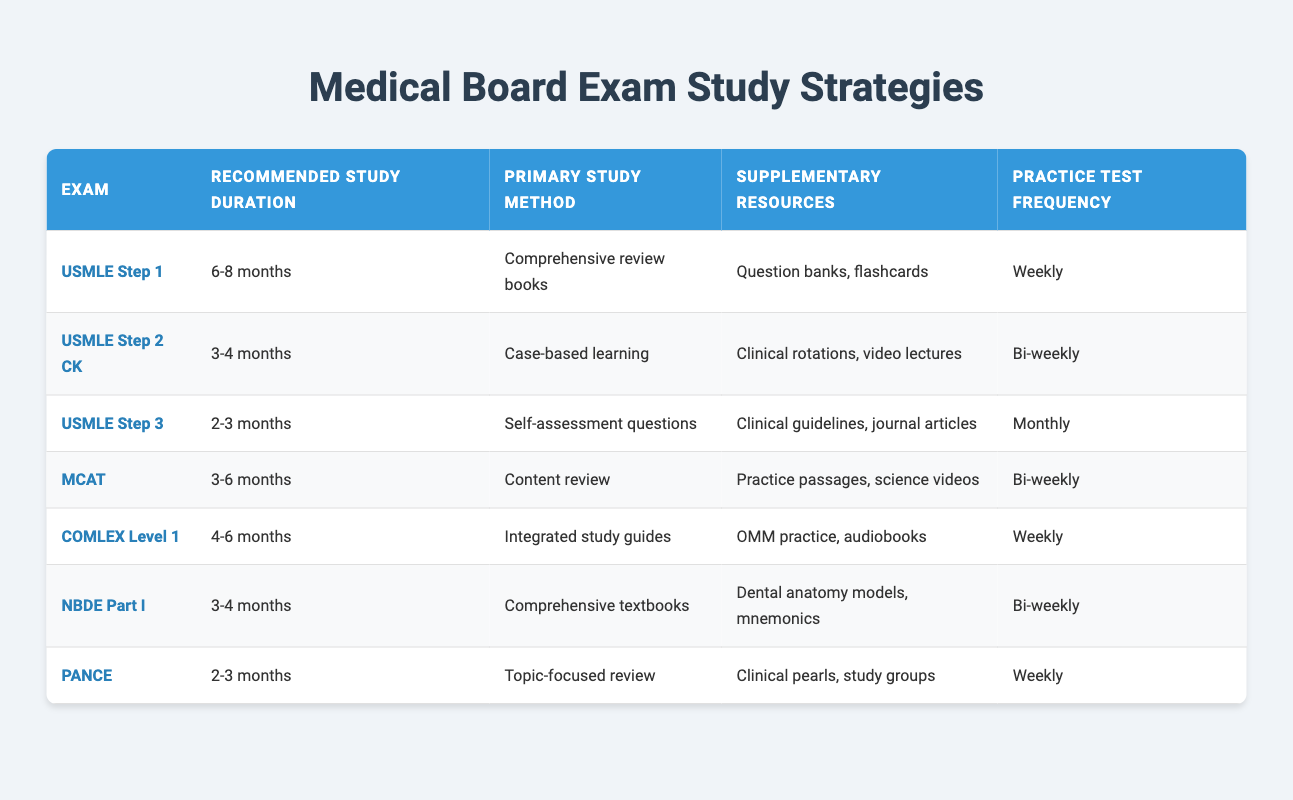What is the recommended study duration for USMLE Step 1? The table shows that the recommended study duration for USMLE Step 1 is "6-8 months". This information can be found directly in the corresponding row for this exam.
Answer: 6-8 months What is the primary study method for the MCAT? According to the table, the primary study method for the MCAT is "Content review". This is stated in the row related to the MCAT.
Answer: Content review How often should a student take practice tests for COMLEX Level 1? The table indicates that students should take practice tests "Weekly" for COMLEX Level 1. This detail is given in the respective row under the Practice Test Frequency column.
Answer: Weekly Which exams have a primary study method that includes case-based learning? The only exam listed that includes "Case-based learning" as a primary study method is USMLE Step 2 CK. This can be determined by reviewing the Primary Study Method column and identifying unique entries.
Answer: USMLE Step 2 CK What is the average recommended study duration for exams listed in the table? First, we convert the given ranges into numerical values. For USMLE Step 1, the average is 7 months, for Step 2 CK it is 3.5 months, for Step 3 it is 2.5 months, for MCAT it is 4.5 months, for COMLEX Level 1 it is 5 months, for NBDE Part I it is 3.5 months, and for PANCE it is 2.5 months. Now summing these values gives us a total of 28 months. There are 7 exams, so we divide 28 by 7, resulting in an average of 4 months.
Answer: 4 months Is it true that the USMLE Step 3 has the shortest recommended study duration? Looking at the table, USMLE Step 3 has a recommended study duration of "2-3 months", which is shorter than the durations listed for all other exams. Therefore, the statement is true as this is a factual check against the data presented.
Answer: Yes How many exams have a practice test frequency of weekly? By reviewing the Practice Test Frequency column, we identify that USMLE Step 1, COMLEX Level 1, and PANCE all have a practice test frequency of "Weekly". There are three instances of this frequency.
Answer: 3 exams What supplementary resources are recommended for NBDE Part I? The table states that for NBDE Part I, the recommended supplementary resources include "Dental anatomy models, mnemonics". This information is available in the corresponding row for this exam.
Answer: Dental anatomy models, mnemonics Which exam has the longest recommended study duration and what is it? A review of the Recommended Study Duration column shows that USMLE Step 1 has the longest duration of "6-8 months". This can be concluded by comparing the ranges given for each exam in the table.
Answer: USMLE Step 1, 6-8 months 